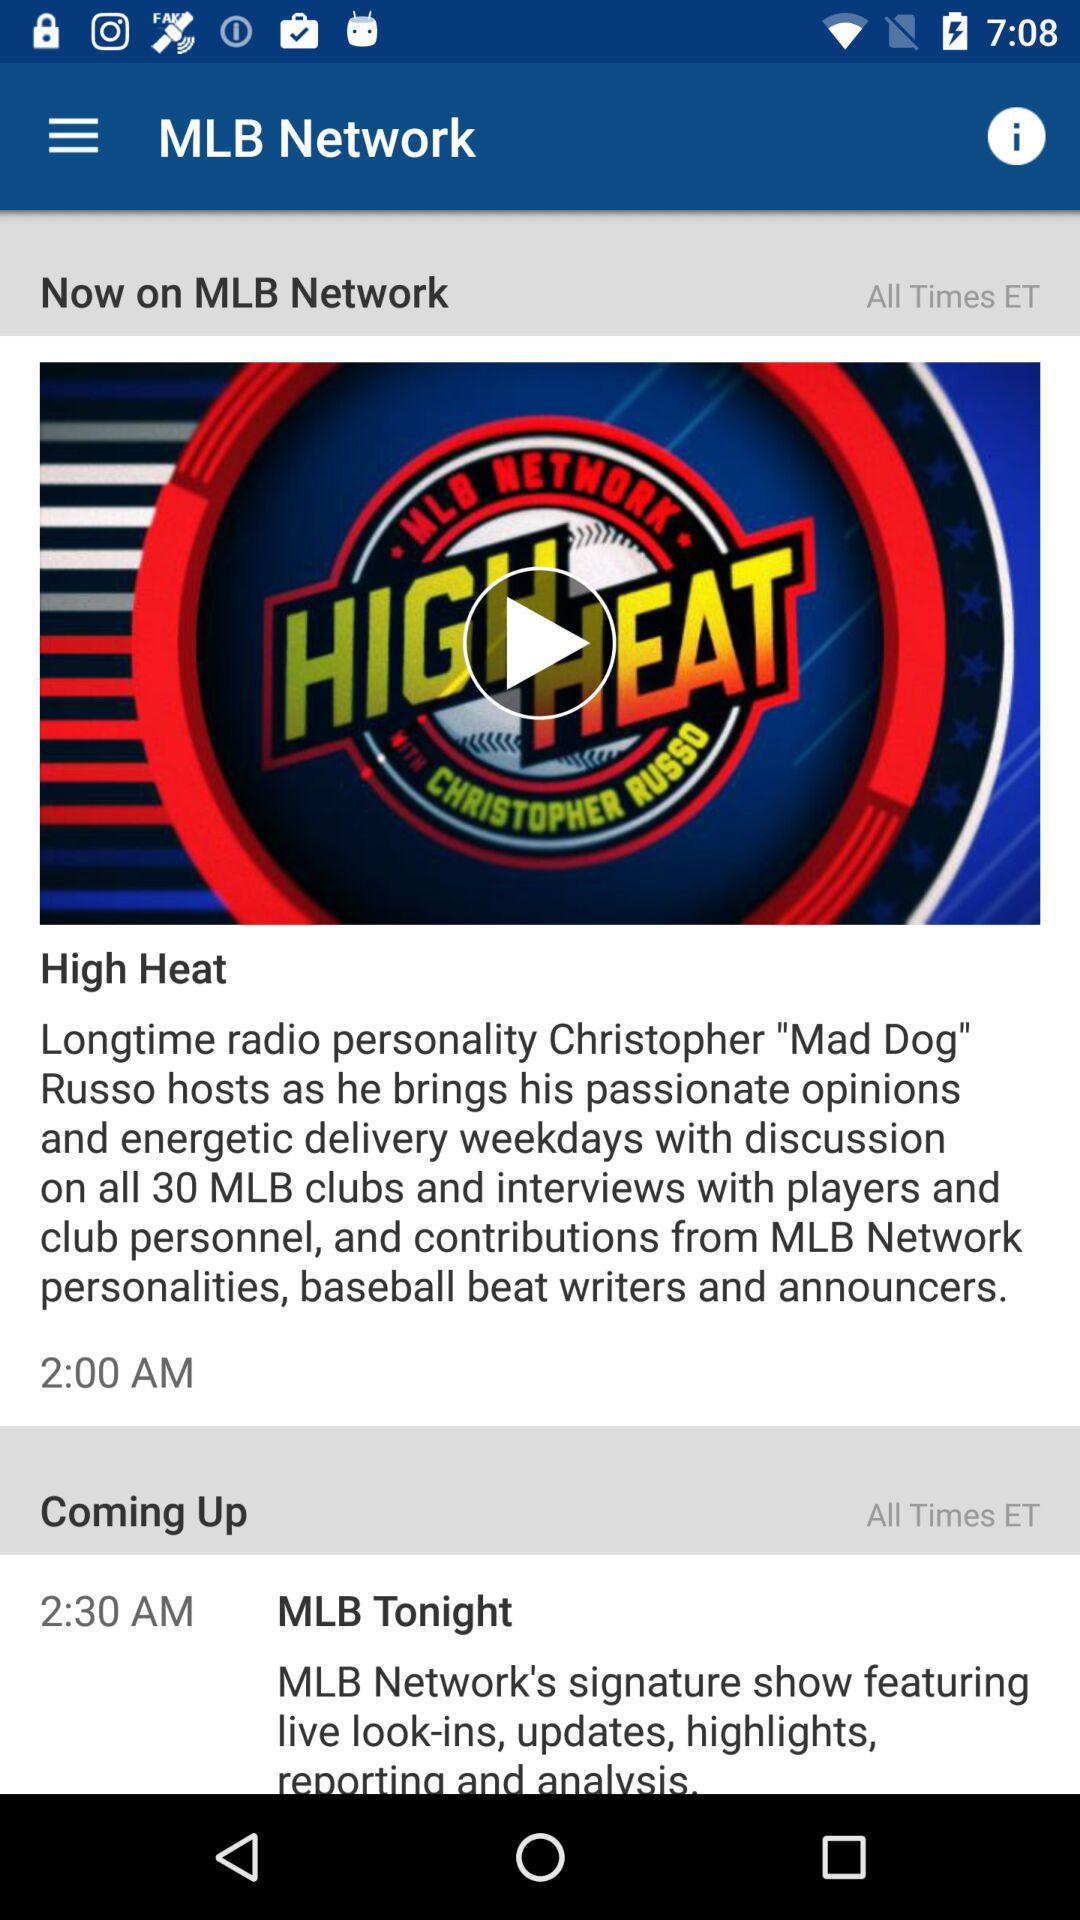What is the showtime of "High Heat"? The showtime is 2:00 AM. 